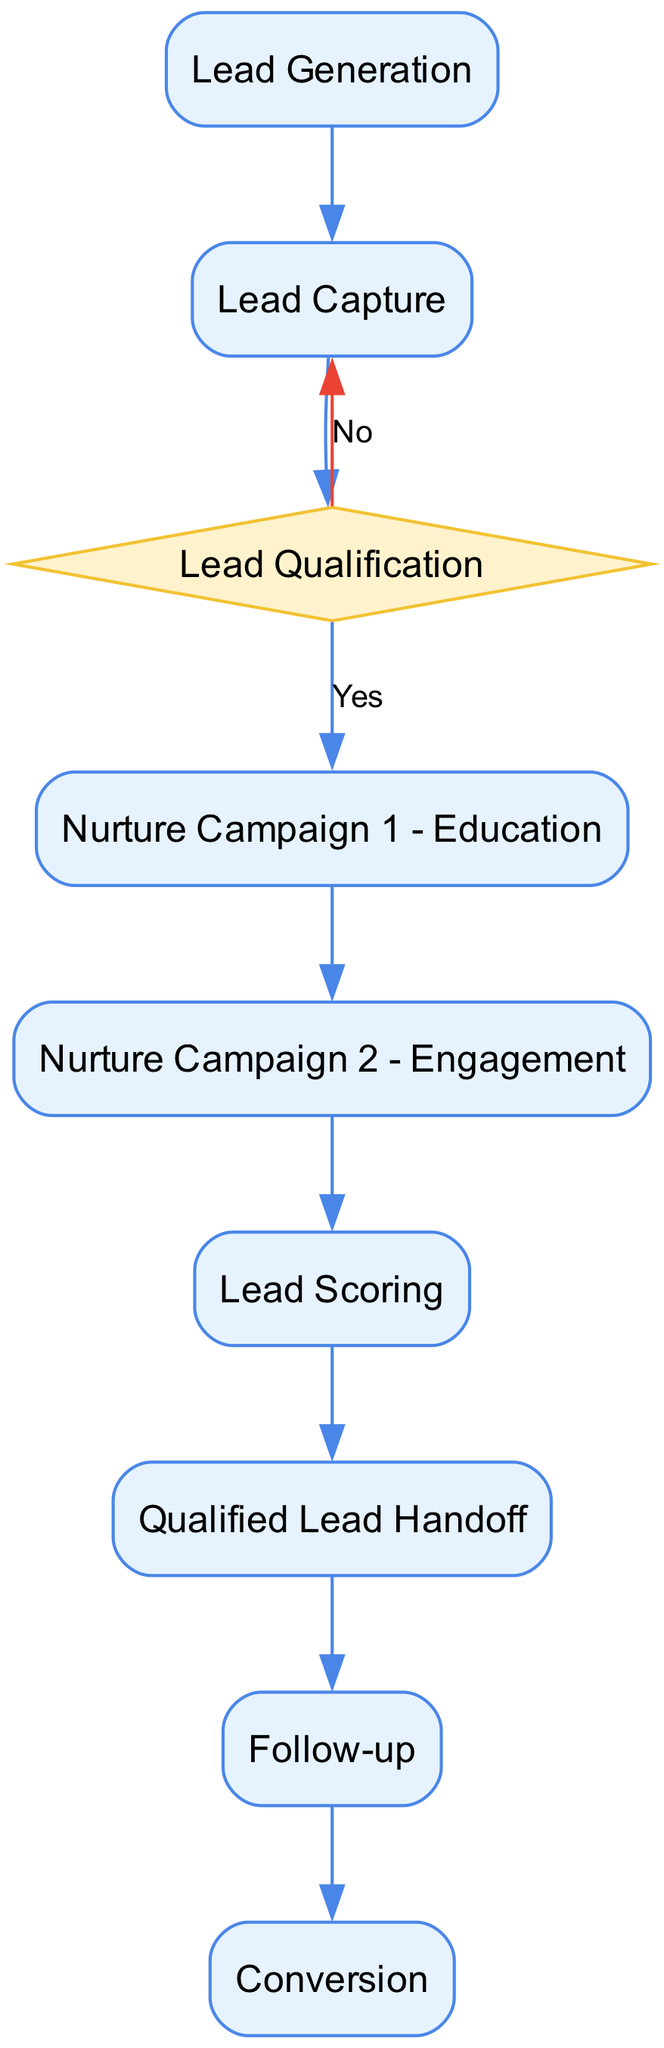What is the first step in the lead nurturing pipeline? The first node in the flowchart is "Lead Generation," which indicates that identifying potential property buyers and sellers is the initial step in the process.
Answer: Lead Generation How many total nodes are present in the diagram? The diagram contains nine nodes, representing each distinct process or decision in the lead nurturing pipeline.
Answer: Nine What is the type of the node "Lead Qualification"? The node "Lead Qualification" is classified as a decision node, which indicates that there is an evaluation process involved in this stage.
Answer: Decision What follows after "Lead Qualification"? After "Lead Qualification," the next step is "Nurture Campaign 1 - Education," which suggests educational content is sent following the qualification of leads.
Answer: Nurture Campaign 1 - Education How many edges are connected to "Follow-up"? The "Follow-up" node has one incoming edge from "Qualified Lead Handoff" and one outgoing edge to "Conversion," totaling two edges connected to it.
Answer: Two What action occurs if a lead is qualified? If a lead is qualified, the process indicates a transfer to the "Qualified Lead Handoff," which directs the leads to the sales team for further action.
Answer: Qualified Lead Handoff What type of content is sent in "Nurture Campaign 1"? The content in "Nurture Campaign 1 - Education" consists of educational material about market trends and property buying tips, aimed at nurturing potential leads.
Answer: Educational content What is the outcome of the last step in the pipeline? The final step in the pipeline is "Conversion," which signifies that the lead is successfully converted into a client.
Answer: Conversion Which two nodes are connected by a decision edge? The "Lead Qualification" node is connected by decision edges to both "Nurture Campaign 1 - Education" (for qualified leads) and the previous node (for unqualified leads), reflecting the branching based on qualification results.
Answer: Lead Qualification and Nurture Campaign 1 - Education 